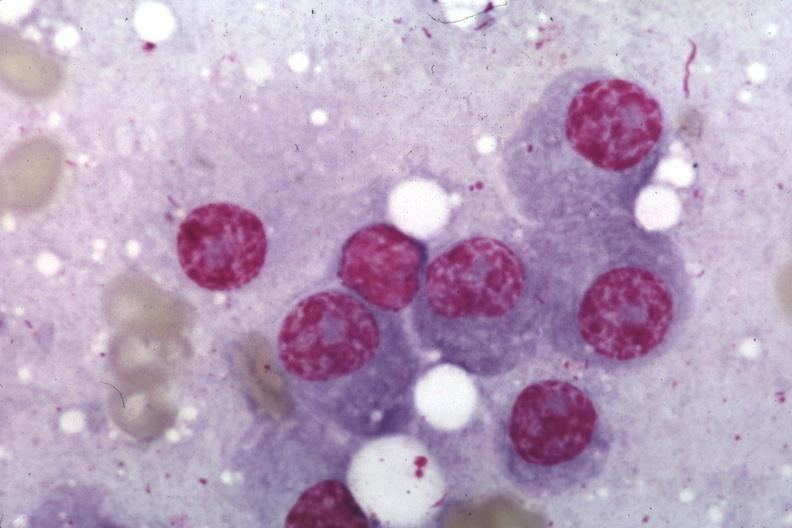s glomerulosa present?
Answer the question using a single word or phrase. No 